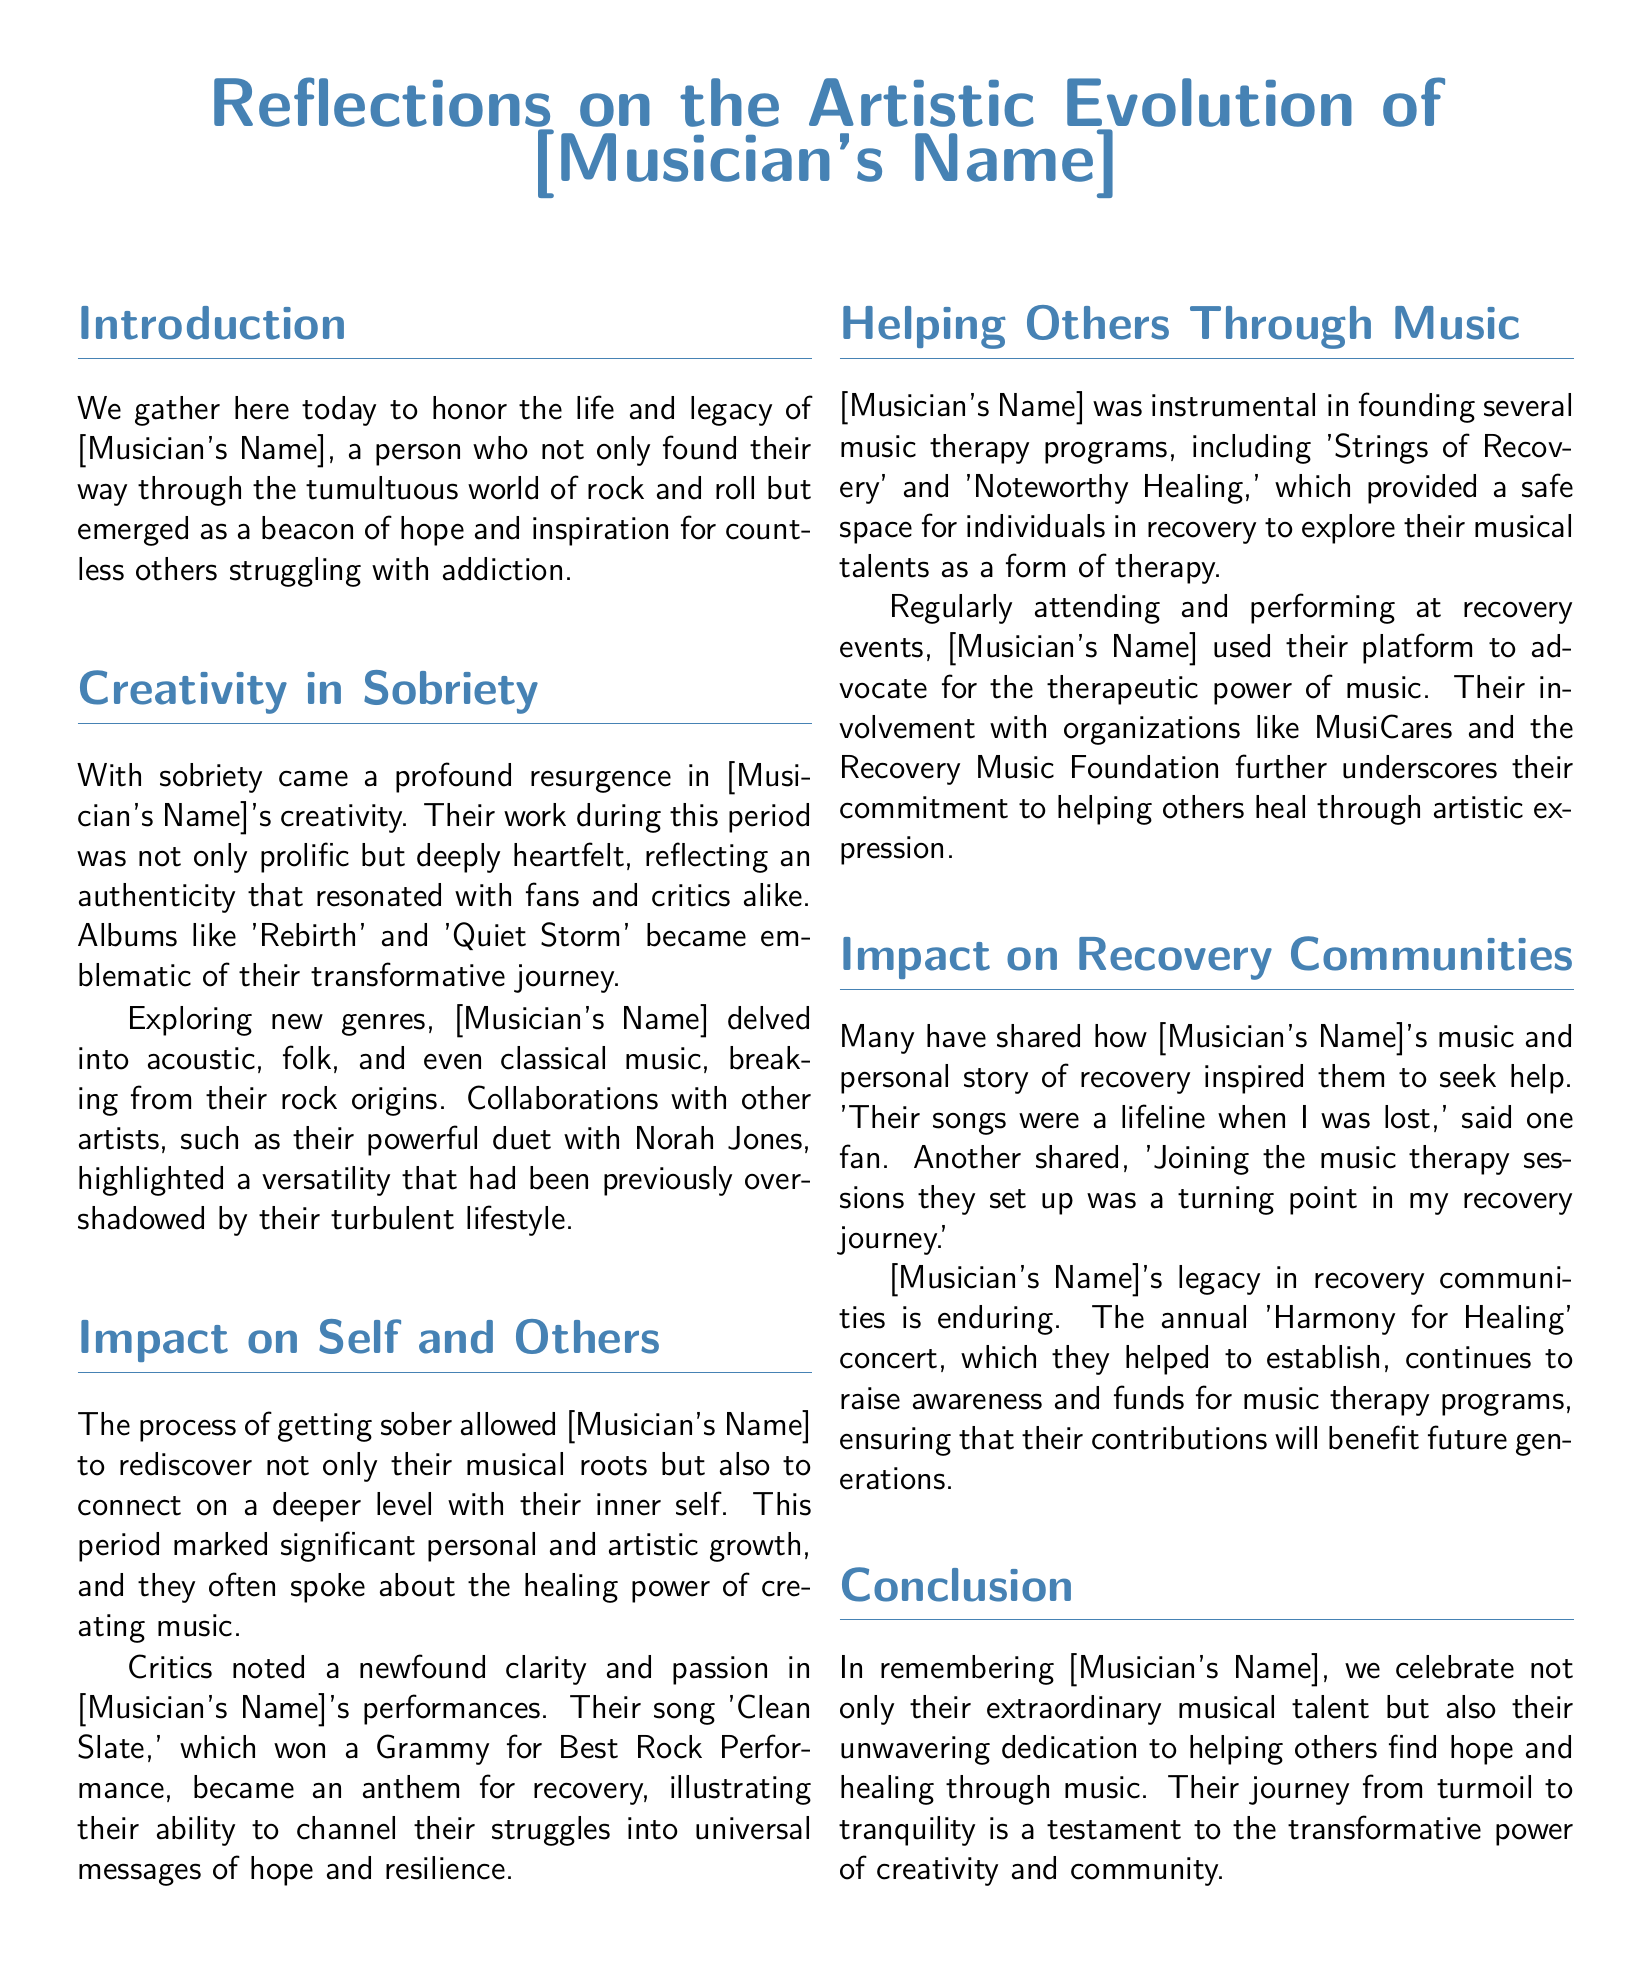What were the names of two albums released during sobriety? The document mentions albums like 'Rebirth' and 'Quiet Storm' as emblematic of their transformative journey during sobriety.
Answer: 'Rebirth' and 'Quiet Storm' What genre did [Musician's Name] explore while sober? The document states that they delved into acoustic, folk, and even classical music, breaking from their rock origins.
Answer: Acoustic, folk, and classical music What award did the song 'Clean Slate' win? The document specifies that 'Clean Slate' won a Grammy for Best Rock Performance, illustrating its impact as an anthem for recovery.
Answer: Grammy for Best Rock Performance What are the names of two music therapy programs founded by [Musician's Name]? According to the document, the musician founded programs called 'Strings of Recovery' and 'Noteworthy Healing.'
Answer: 'Strings of Recovery' and 'Noteworthy Healing' What was the purpose of the 'Harmony for Healing' concert? The document mentions that this concert helps to raise awareness and funds for music therapy programs.
Answer: Raise awareness and funds for music therapy programs Why did [Musician's Name]'s music inspire others? The document notes that their personal story of recovery and the lifeline nature of their songs encouraged individuals to seek help.
Answer: Their personal story of recovery What was the significance of [Musician's Name]'s involvement with organizations like MusiCares? The document outlines that their involvement underscores their commitment to helping others heal through artistic expression.
Answer: Helping others heal through artistic expression What transformation is celebrated in the conclusion of the eulogy? The conclusion refers to the transformation from turmoil to tranquility as a testament to the power of creativity and community.
Answer: Turmoil to tranquility 